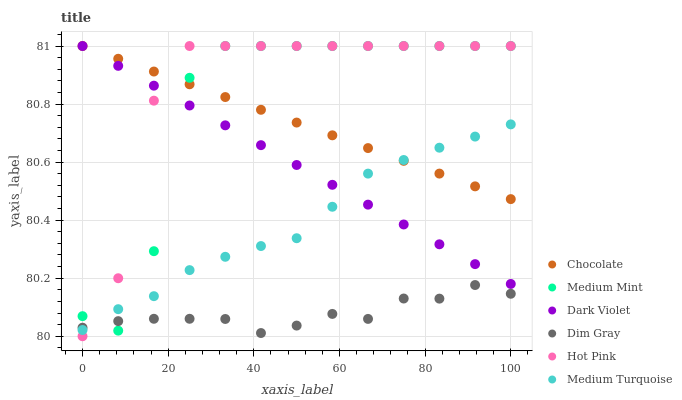Does Dim Gray have the minimum area under the curve?
Answer yes or no. Yes. Does Hot Pink have the maximum area under the curve?
Answer yes or no. Yes. Does Hot Pink have the minimum area under the curve?
Answer yes or no. No. Does Dim Gray have the maximum area under the curve?
Answer yes or no. No. Is Dark Violet the smoothest?
Answer yes or no. Yes. Is Medium Mint the roughest?
Answer yes or no. Yes. Is Dim Gray the smoothest?
Answer yes or no. No. Is Dim Gray the roughest?
Answer yes or no. No. Does Hot Pink have the lowest value?
Answer yes or no. Yes. Does Dim Gray have the lowest value?
Answer yes or no. No. Does Chocolate have the highest value?
Answer yes or no. Yes. Does Dim Gray have the highest value?
Answer yes or no. No. Is Dim Gray less than Dark Violet?
Answer yes or no. Yes. Is Chocolate greater than Dim Gray?
Answer yes or no. Yes. Does Chocolate intersect Medium Mint?
Answer yes or no. Yes. Is Chocolate less than Medium Mint?
Answer yes or no. No. Is Chocolate greater than Medium Mint?
Answer yes or no. No. Does Dim Gray intersect Dark Violet?
Answer yes or no. No. 